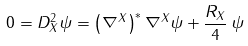Convert formula to latex. <formula><loc_0><loc_0><loc_500><loc_500>0 = D _ { X } ^ { 2 } \psi = \left ( \nabla ^ { X } \right ) ^ { * } \nabla ^ { X } \psi + \frac { R _ { X } } { 4 } \, \psi</formula> 